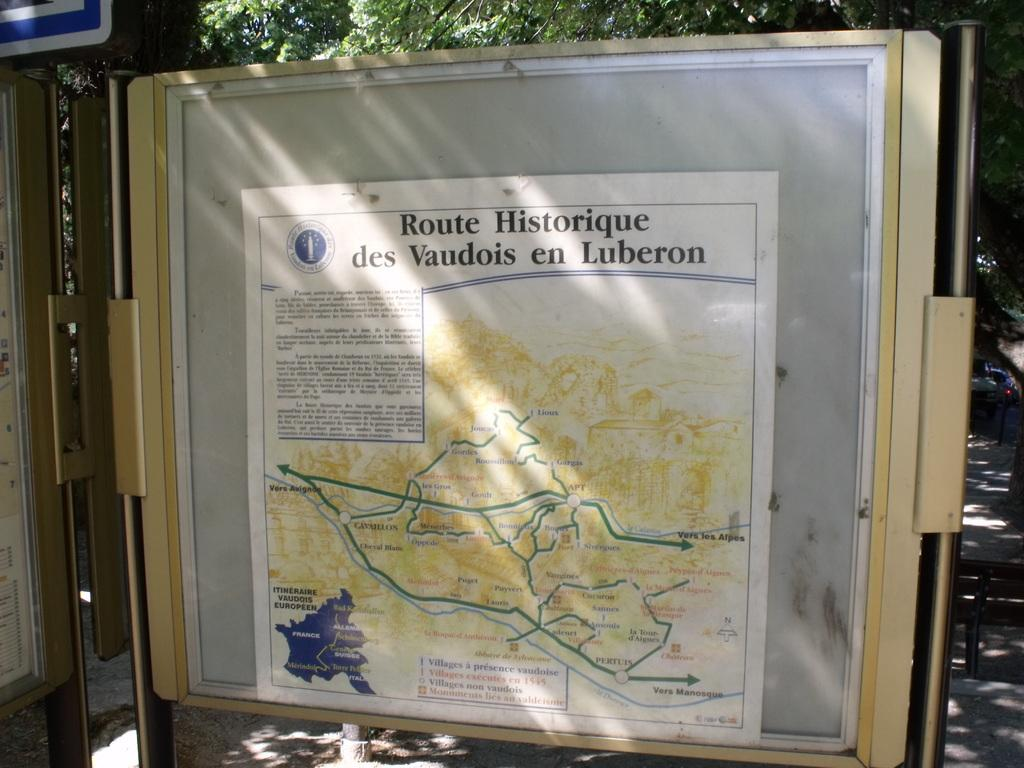What is on the board in the image? There is a poster on a board in the image. What is at the bottom of the image? There is a road at the bottom of the image. What can be seen in the background of the image? There are trees in the background of the image. Can you see a quince hanging from the trees in the background? There is no quince visible in the image; only trees are present in the background. Is there a string attached to the poster on the board? There is no string attached to the poster on the board in the image. 